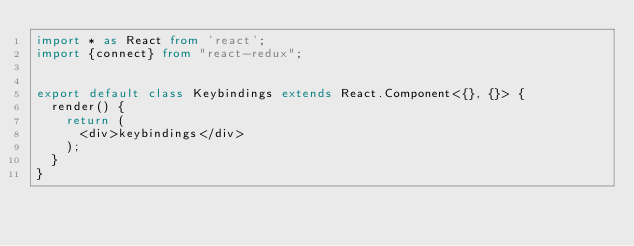Convert code to text. <code><loc_0><loc_0><loc_500><loc_500><_TypeScript_>import * as React from 'react';
import {connect} from "react-redux";


export default class Keybindings extends React.Component<{}, {}> {
  render() {
    return (
      <div>keybindings</div>
    );
  }
}
</code> 